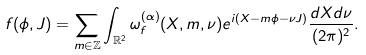<formula> <loc_0><loc_0><loc_500><loc_500>f ( \phi , J ) = \sum _ { m \in \mathbb { Z } } \int _ { \mathbb { R } ^ { 2 } } \omega _ { f } ^ { ( \alpha ) } ( X , m , \nu ) e ^ { i ( X - m \phi - \nu J ) } \frac { d X d \nu } { ( 2 \pi ) ^ { 2 } } .</formula> 